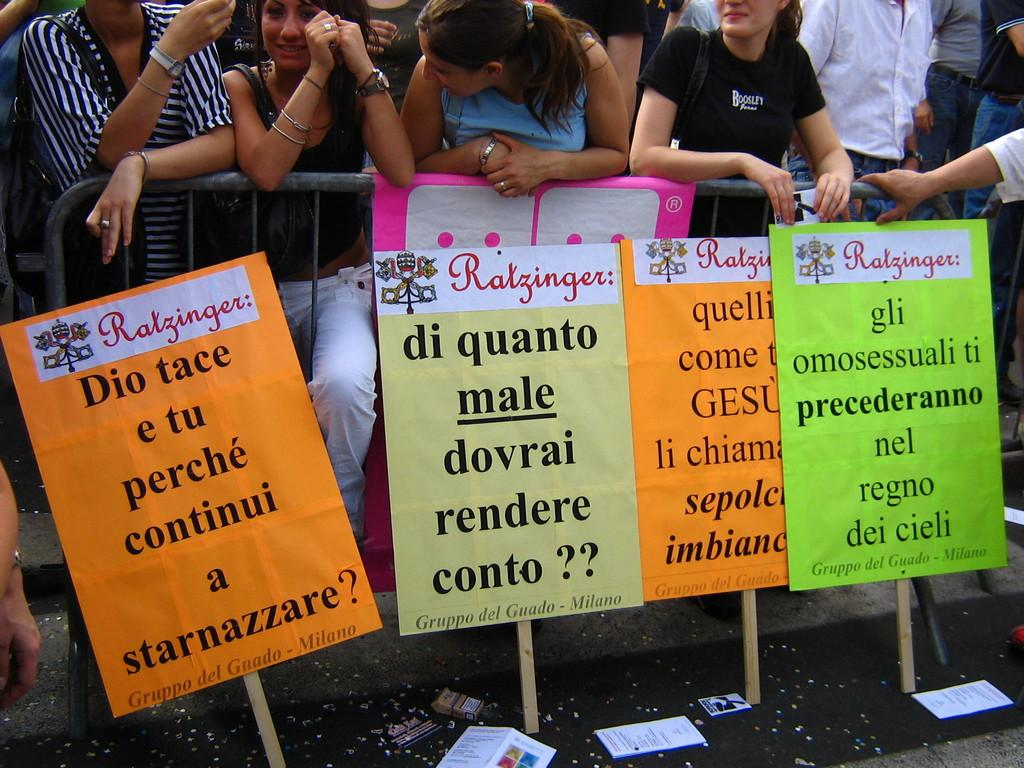What are the people in the image doing? There is a group of people standing in the image. What can be seen in the hands of some people in the image? There are placards in the image. What is lying on the road in the image? Papers are lying on the road in the image. What is blocking the road in the image? There is a barricade in the image. Can you hear the crow cawing in the image? There is no crow present in the image, so it is not possible to hear it cawing. 